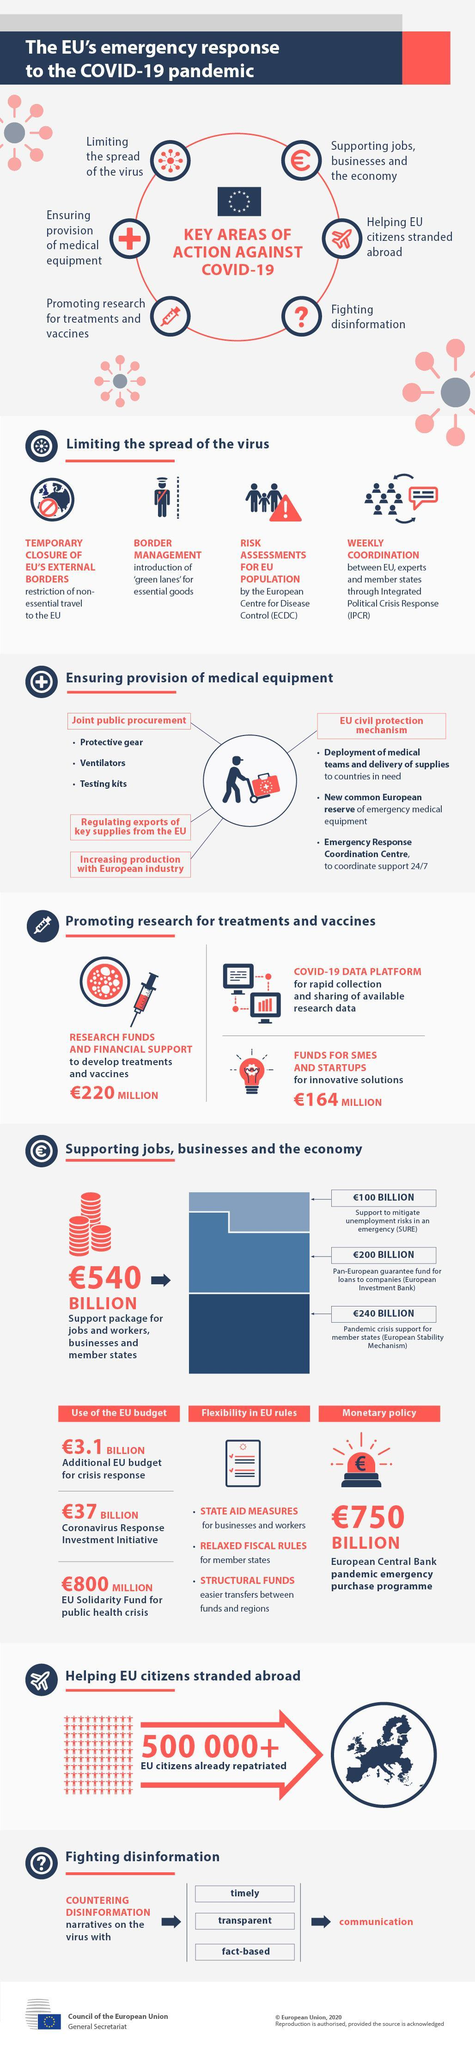How much is the research fund granted (in euros) to develop treatments & vaccines for COVID-19 virus in the EU?
Answer the question with a short phrase. 220 MILLION How much is the fund granted (in euros) by the EU for SMEs & startups for creating innovative solutions? 164 MILLION How many EU citizens stranded abroad were brought back to the country? 500 000+ 